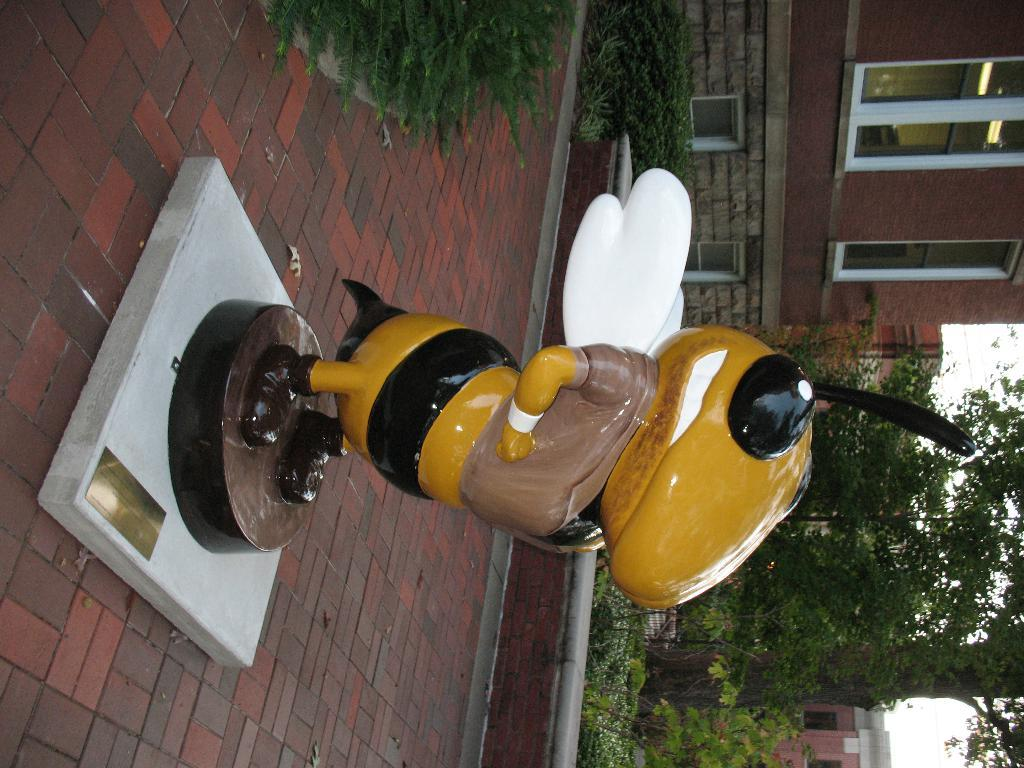What is the main subject of the image? There is a sculpture of a honey bee in the middle of the image. What can be seen on the right side of the image? There are trees and buildings on the right side of the image. What type of surface is on the left side of the image? There is pavement on the left side of the image. What is visible at the top of the image? There are plants visible at the top of the image. What type of profit can be seen from the honey bee sculpture in the image? There is no indication of profit or any financial aspect related to the honey bee sculpture in the image. 